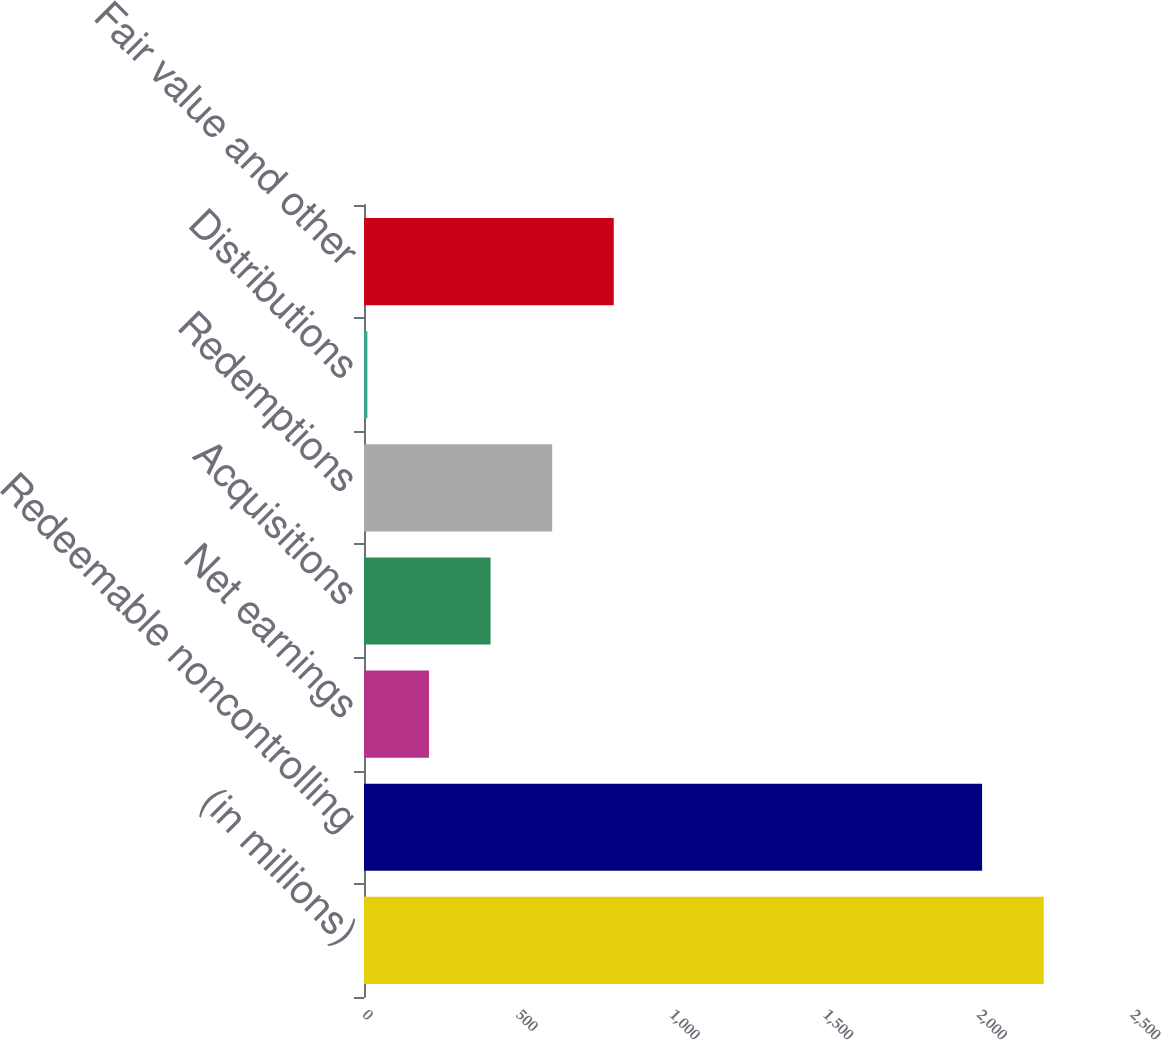Convert chart to OTSL. <chart><loc_0><loc_0><loc_500><loc_500><bar_chart><fcel>(in millions)<fcel>Redeemable noncontrolling<fcel>Net earnings<fcel>Acquisitions<fcel>Redemptions<fcel>Distributions<fcel>Fair value and other<nl><fcel>2212.5<fcel>2012<fcel>211.5<fcel>412<fcel>612.5<fcel>11<fcel>813<nl></chart> 